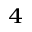<formula> <loc_0><loc_0><loc_500><loc_500>_ { 4 }</formula> 